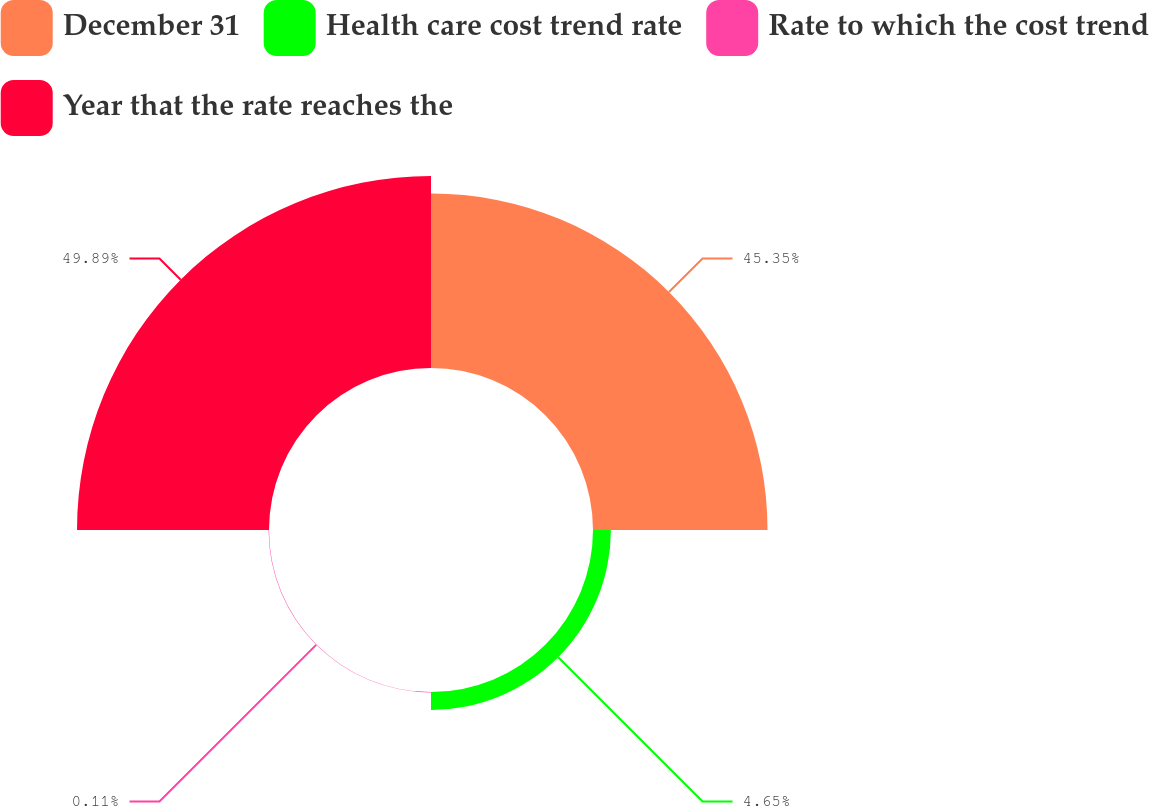<chart> <loc_0><loc_0><loc_500><loc_500><pie_chart><fcel>December 31<fcel>Health care cost trend rate<fcel>Rate to which the cost trend<fcel>Year that the rate reaches the<nl><fcel>45.35%<fcel>4.65%<fcel>0.11%<fcel>49.89%<nl></chart> 